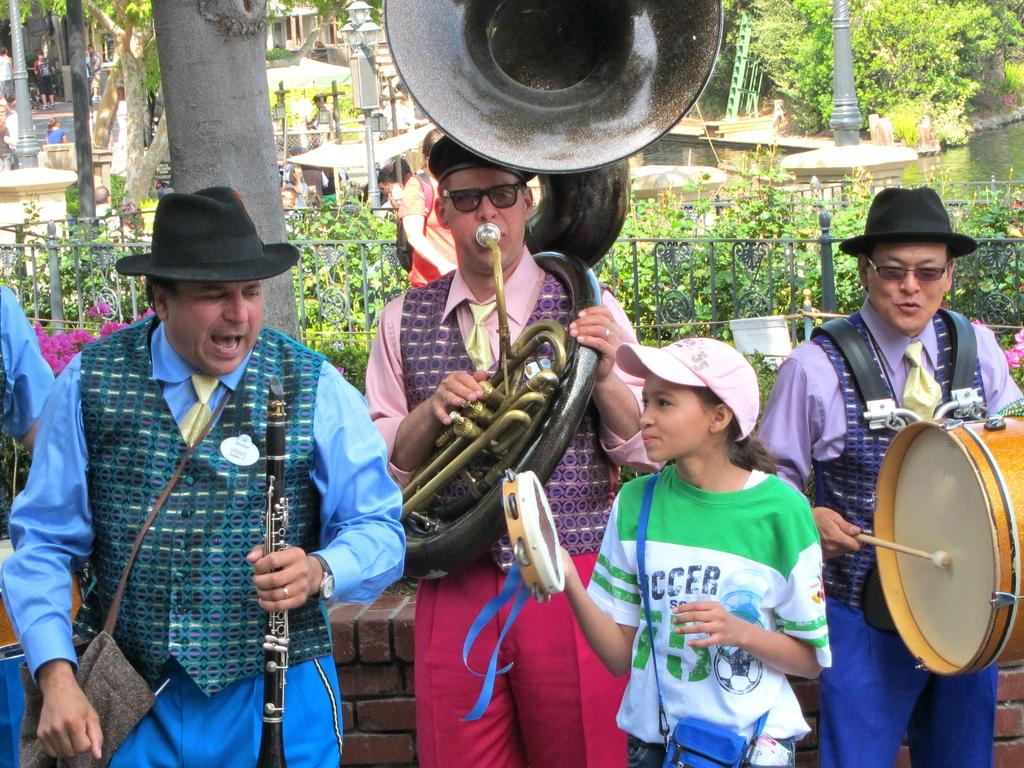How many people are in the group that is visible in the image? There is a group of persons in the image, but the exact number is not specified. What are the people in the group doing? The group of persons are playing music. What type of natural environment can be seen in the image? There are trees visible in the image, and a river is in the background. What type of lunch is being exchanged between the group members in the image? There is no mention of lunch or any exchange of food in the image; the group is playing music. 